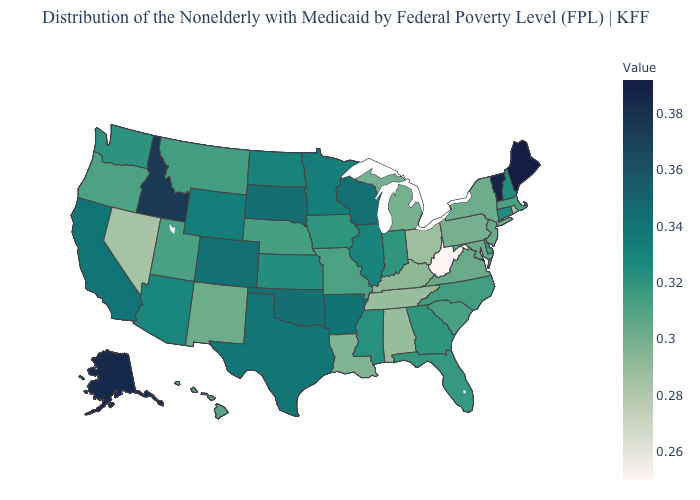Does West Virginia have the lowest value in the USA?
Concise answer only. Yes. Which states hav the highest value in the West?
Answer briefly. Alaska. Among the states that border Washington , which have the highest value?
Be succinct. Idaho. 